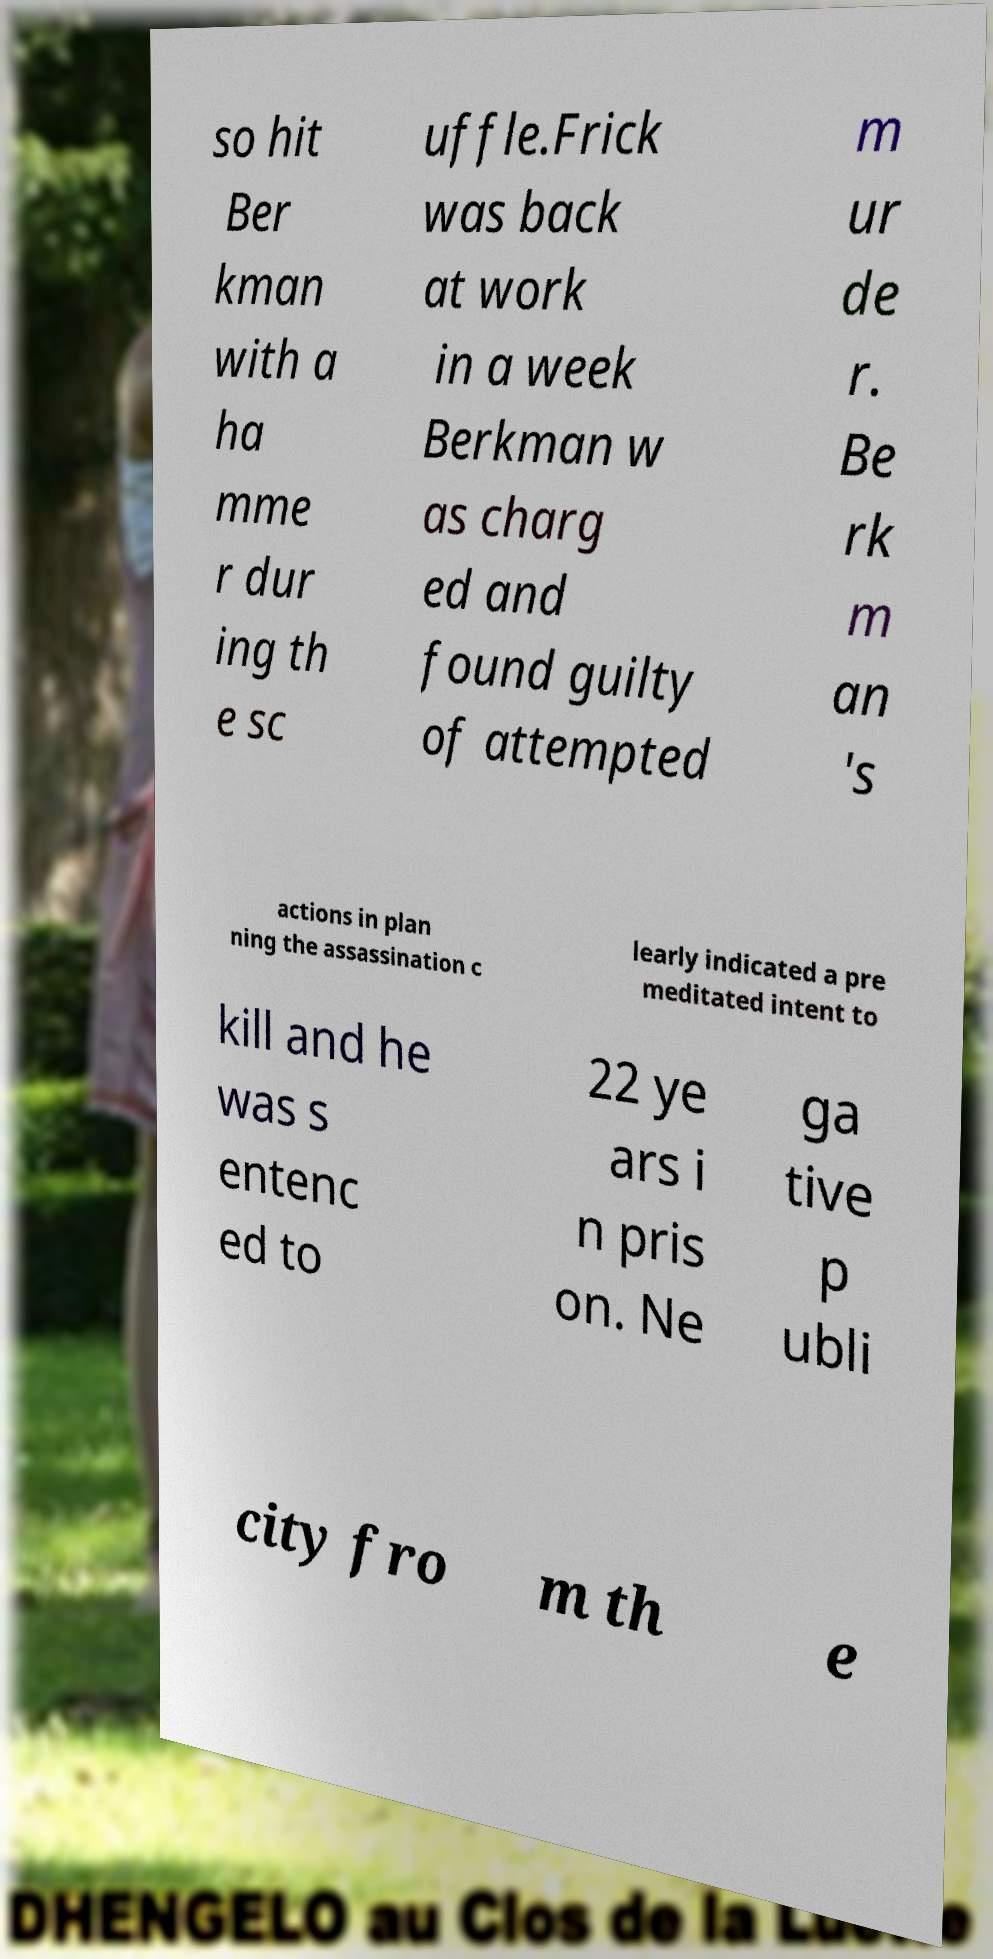For documentation purposes, I need the text within this image transcribed. Could you provide that? so hit Ber kman with a ha mme r dur ing th e sc uffle.Frick was back at work in a week Berkman w as charg ed and found guilty of attempted m ur de r. Be rk m an 's actions in plan ning the assassination c learly indicated a pre meditated intent to kill and he was s entenc ed to 22 ye ars i n pris on. Ne ga tive p ubli city fro m th e 